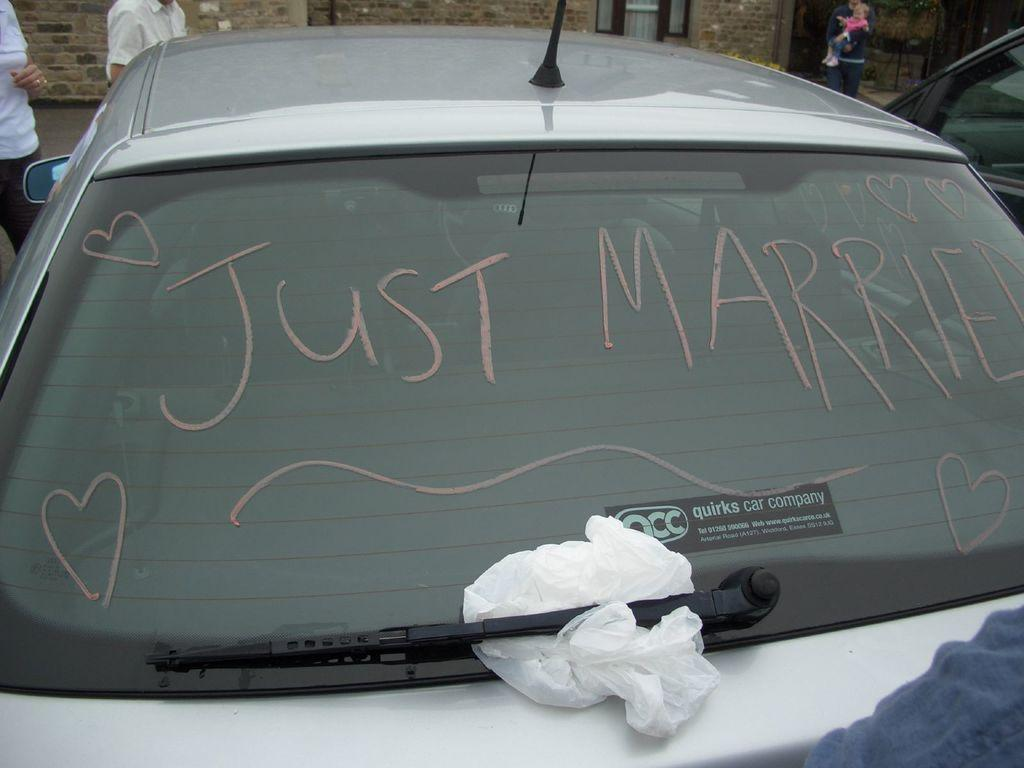What types of objects can be seen in the image? There are vehicles in the image. What else can be seen in the image besides vehicles? There is a wall and people in the image. Can you describe the people in the image? Yes, there is a person carrying a baby in the image. Are there any additional details about the vehicles in the image? Yes, there is a sticker on a car in the image. What type of industry is depicted in the image? There is no specific industry depicted in the image; it primarily features vehicles, a wall, and people. Can you tell me how many lawyers are involved in the image? There is no mention of lawyers or any legal matters in the image. 